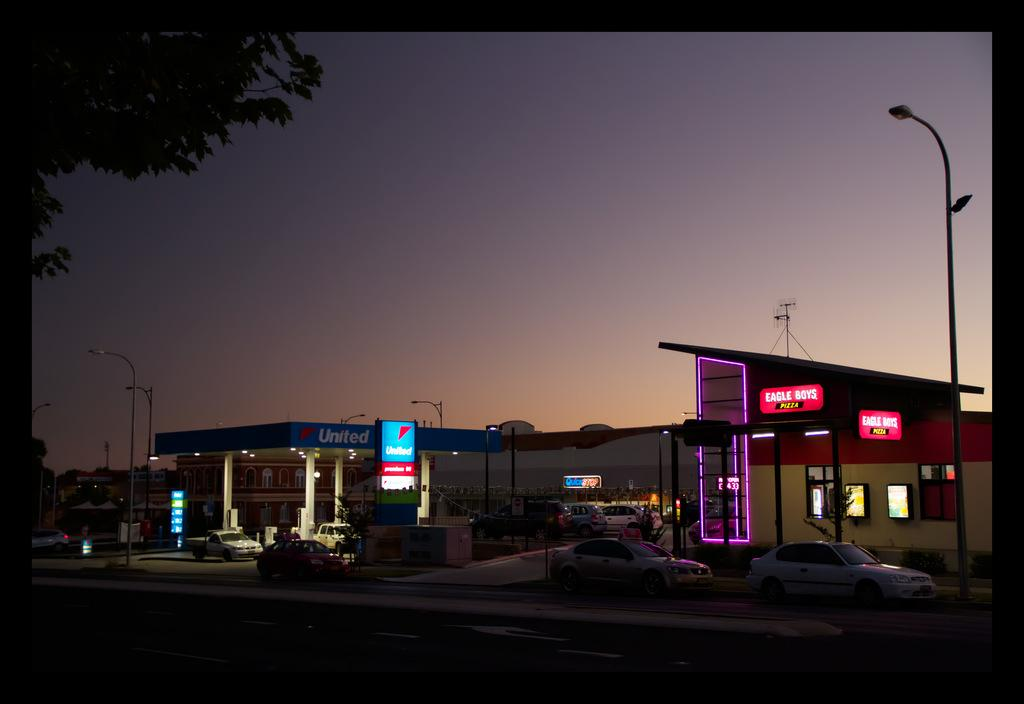What type of establishment can be seen in the image? There is a petrol bunk in the image. What other structures are present in the image? There are buildings in the image. Are there any vehicles in the image? Yes, there are vehicles in the image. What type of infrastructure is present in the image? There are light poles in the image. What type of advertisements are present in the image? There are hoardings in the image. What is the purpose of the board in the image? There is a board in the image, and something is written on it. What type of vegetation is present in the image? There is a tree in the image. What part of the natural environment is visible in the image? The sky is visible in the image. What type of objects can be seen in the image? There are objects in the image. What type of care is being provided to the field in the image? There is no field present in the image, so it is not possible to determine if any care is being provided. 